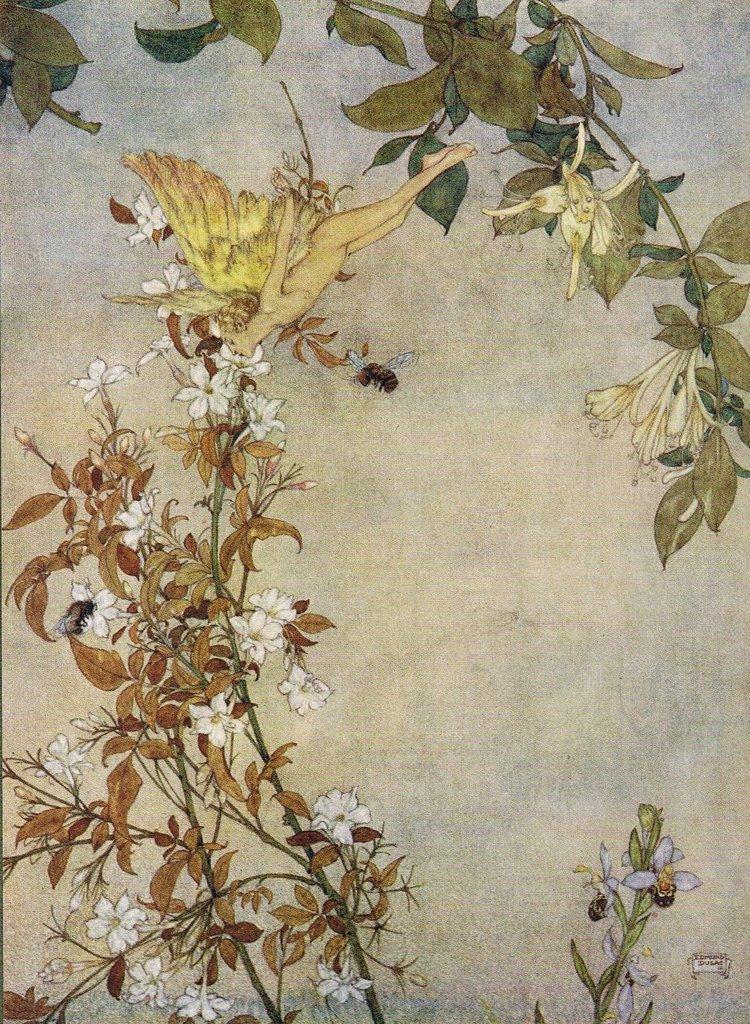Can you describe this image briefly? In this picture I can see the art, where I can see plants, on which I can see flowers on it and I can see an insect and a human with wings. 